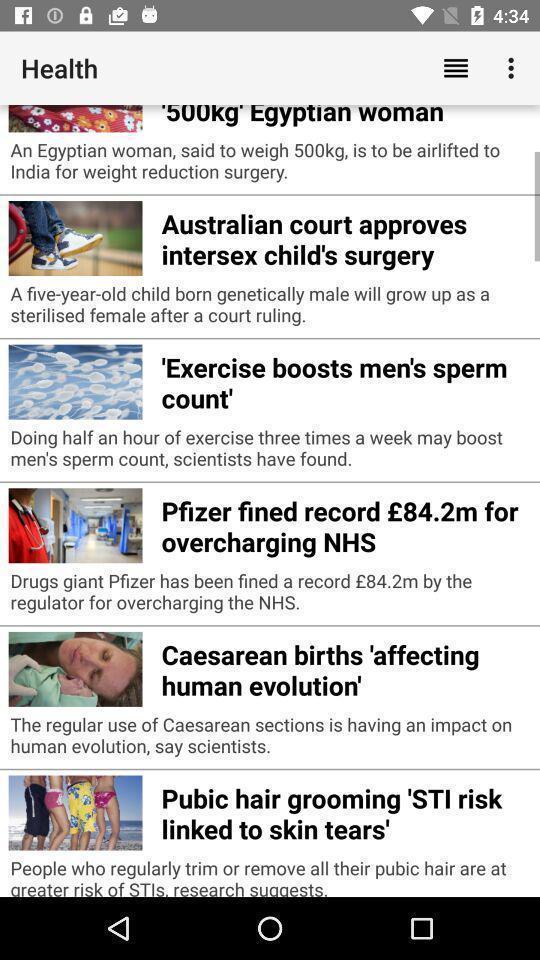What details can you identify in this image? Screen showing health page with various posts. 